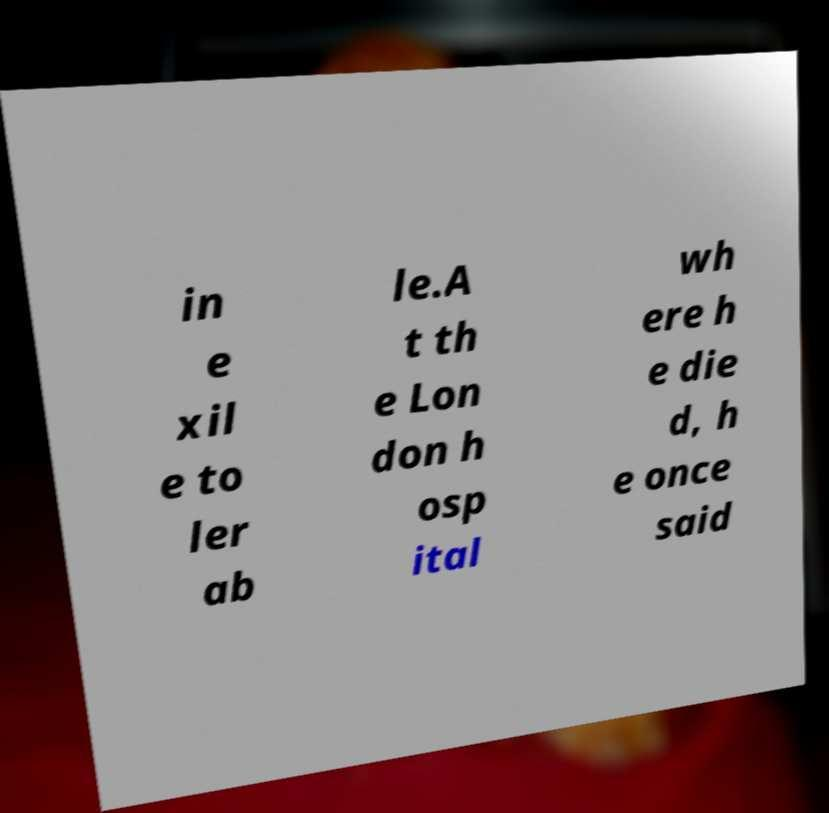What messages or text are displayed in this image? I need them in a readable, typed format. in e xil e to ler ab le.A t th e Lon don h osp ital wh ere h e die d, h e once said 